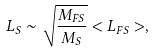Convert formula to latex. <formula><loc_0><loc_0><loc_500><loc_500>L _ { S } \sim \sqrt { \frac { M _ { F S } } { M _ { S } } } < L _ { F S } > ,</formula> 